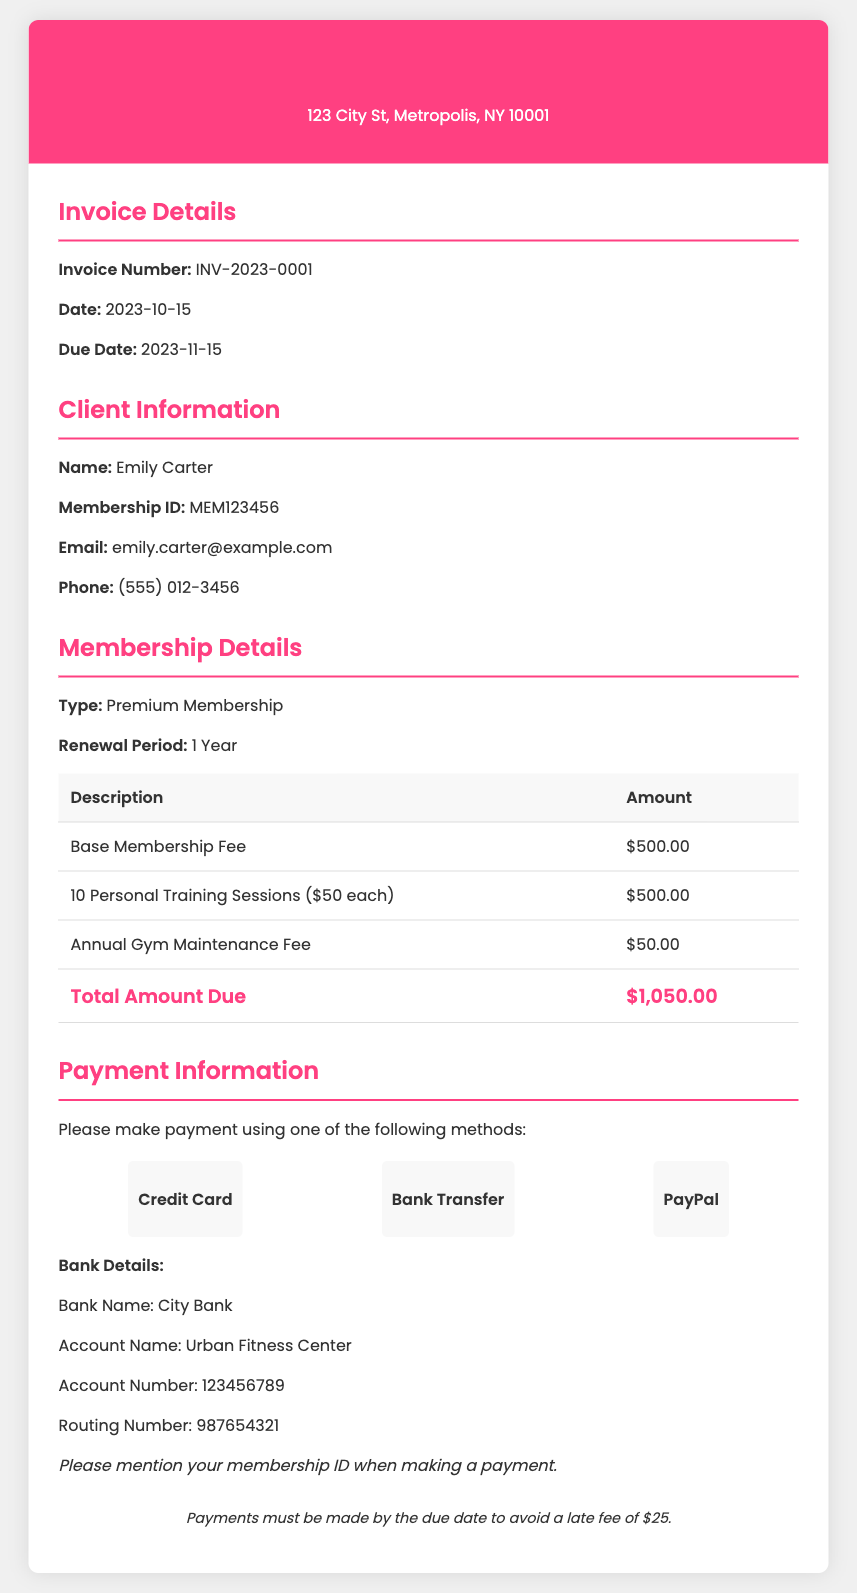What is the name of the gym? The gym's name is listed in the header of the document, which is Urban Fitness Center.
Answer: Urban Fitness Center What is the invoice number? The invoice number is provided in the invoice details section, which is INV-2023-0001.
Answer: INV-2023-0001 When is the due date for payment? The due date is specified in the invoice details and is set for 2023-11-15.
Answer: 2023-11-15 What type of membership is being renewed? The type of membership is stated in the membership details section as Premium Membership.
Answer: Premium Membership How many personal training sessions are included? The number of personal training sessions is noted in the membership details and is 10 sessions.
Answer: 10 sessions What is the total amount due? The total amount due is found in the membership details table and is $1,050.00.
Answer: $1,050.00 What is the late fee amount? The late fee amount is indicated in the terms section, which is $25.
Answer: $25 What payment methods are available? The document lists the payment methods available, which are Credit Card, Bank Transfer, and PayPal.
Answer: Credit Card, Bank Transfer, PayPal What is the annual gym maintenance fee? The annual gym maintenance fee is included in the membership details and is $50.00.
Answer: $50.00 What should be mentioned while making a payment? It is specified in the payment details that the membership ID should be mentioned while making a payment.
Answer: Membership ID 